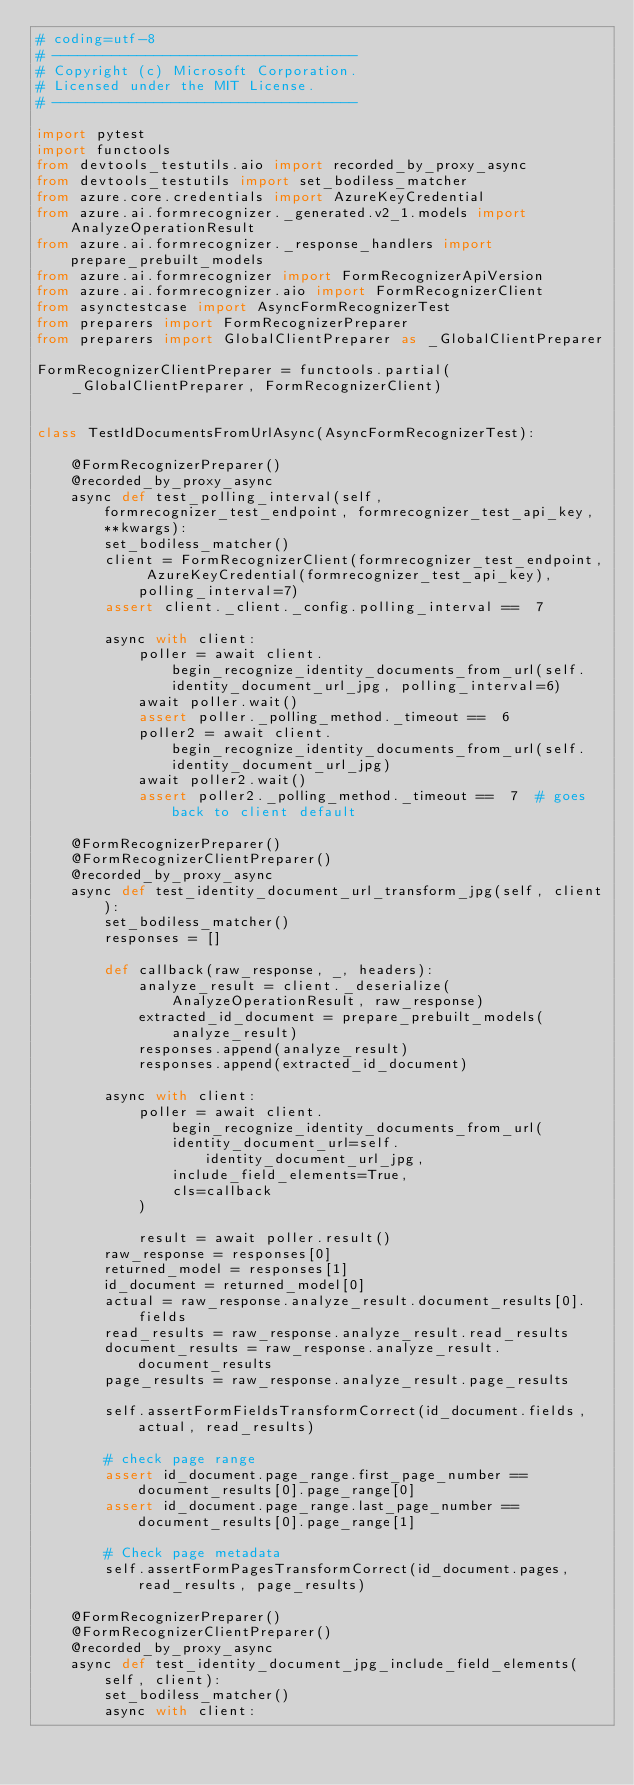Convert code to text. <code><loc_0><loc_0><loc_500><loc_500><_Python_># coding=utf-8
# ------------------------------------
# Copyright (c) Microsoft Corporation.
# Licensed under the MIT License.
# ------------------------------------

import pytest
import functools
from devtools_testutils.aio import recorded_by_proxy_async
from devtools_testutils import set_bodiless_matcher
from azure.core.credentials import AzureKeyCredential
from azure.ai.formrecognizer._generated.v2_1.models import AnalyzeOperationResult
from azure.ai.formrecognizer._response_handlers import prepare_prebuilt_models
from azure.ai.formrecognizer import FormRecognizerApiVersion
from azure.ai.formrecognizer.aio import FormRecognizerClient
from asynctestcase import AsyncFormRecognizerTest
from preparers import FormRecognizerPreparer
from preparers import GlobalClientPreparer as _GlobalClientPreparer

FormRecognizerClientPreparer = functools.partial(_GlobalClientPreparer, FormRecognizerClient)


class TestIdDocumentsFromUrlAsync(AsyncFormRecognizerTest):

    @FormRecognizerPreparer()
    @recorded_by_proxy_async
    async def test_polling_interval(self, formrecognizer_test_endpoint, formrecognizer_test_api_key, **kwargs):
        set_bodiless_matcher()
        client = FormRecognizerClient(formrecognizer_test_endpoint, AzureKeyCredential(formrecognizer_test_api_key), polling_interval=7)
        assert client._client._config.polling_interval ==  7

        async with client:
            poller = await client.begin_recognize_identity_documents_from_url(self.identity_document_url_jpg, polling_interval=6)
            await poller.wait()
            assert poller._polling_method._timeout ==  6
            poller2 = await client.begin_recognize_identity_documents_from_url(self.identity_document_url_jpg)
            await poller2.wait()
            assert poller2._polling_method._timeout ==  7  # goes back to client default

    @FormRecognizerPreparer()
    @FormRecognizerClientPreparer()
    @recorded_by_proxy_async
    async def test_identity_document_url_transform_jpg(self, client):
        set_bodiless_matcher()
        responses = []

        def callback(raw_response, _, headers):
            analyze_result = client._deserialize(AnalyzeOperationResult, raw_response)
            extracted_id_document = prepare_prebuilt_models(analyze_result)
            responses.append(analyze_result)
            responses.append(extracted_id_document)

        async with client:
            poller = await client.begin_recognize_identity_documents_from_url(
                identity_document_url=self.identity_document_url_jpg,
                include_field_elements=True,
                cls=callback
            )

            result = await poller.result()
        raw_response = responses[0]
        returned_model = responses[1]
        id_document = returned_model[0]
        actual = raw_response.analyze_result.document_results[0].fields
        read_results = raw_response.analyze_result.read_results
        document_results = raw_response.analyze_result.document_results
        page_results = raw_response.analyze_result.page_results

        self.assertFormFieldsTransformCorrect(id_document.fields, actual, read_results)

        # check page range
        assert id_document.page_range.first_page_number ==  document_results[0].page_range[0]
        assert id_document.page_range.last_page_number ==  document_results[0].page_range[1]

        # Check page metadata
        self.assertFormPagesTransformCorrect(id_document.pages, read_results, page_results)

    @FormRecognizerPreparer()
    @FormRecognizerClientPreparer()
    @recorded_by_proxy_async
    async def test_identity_document_jpg_include_field_elements(self, client):
        set_bodiless_matcher()
        async with client:</code> 